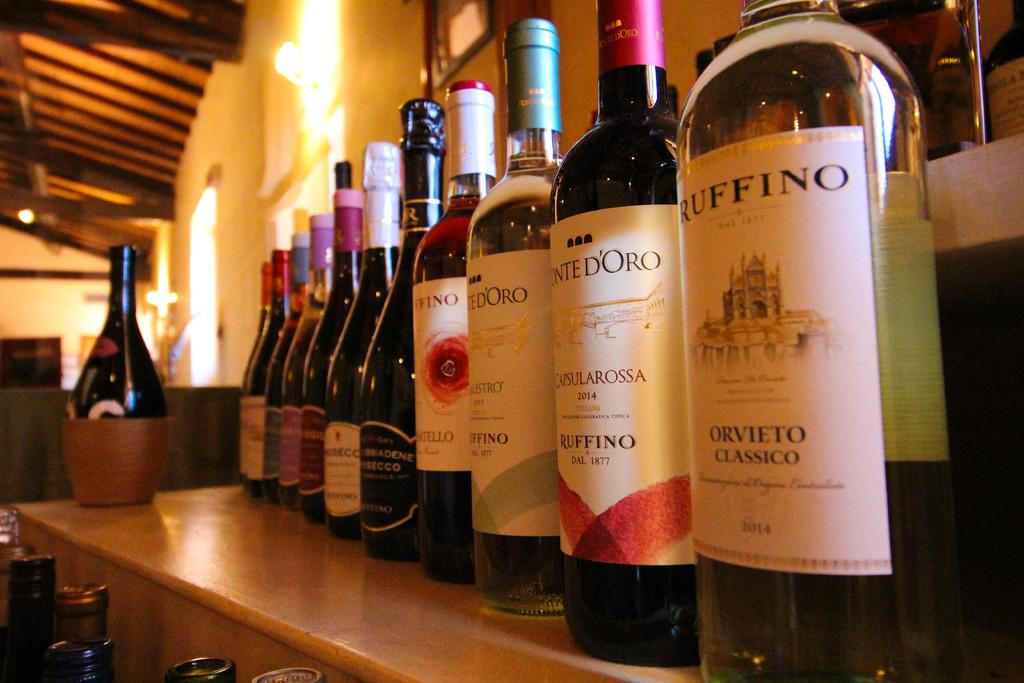<image>
Render a clear and concise summary of the photo. A bottle of Orvieto Classico is next to a bottle of Ruffino. 